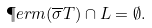Convert formula to latex. <formula><loc_0><loc_0><loc_500><loc_500>\P e r m ( \overline { \sigma } T ) \cap L = \emptyset .</formula> 